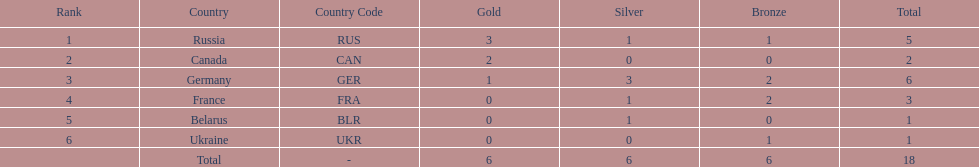What were the only 3 countries to win gold medals at the the 1994 winter olympics biathlon? Russia (RUS), Canada (CAN), Germany (GER). 